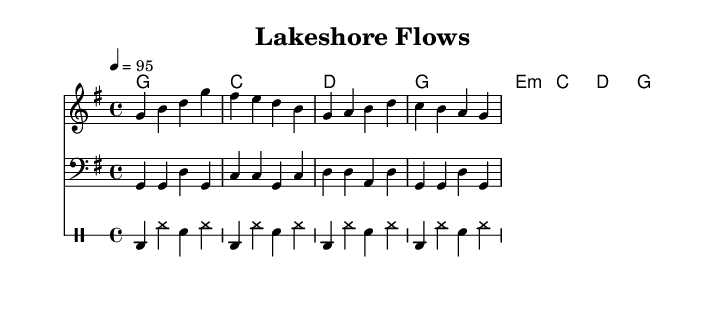What is the key signature of this music? The key signature indicated at the beginning of the score shows one sharp (F#), which corresponds to G major.
Answer: G major What is the time signature of the music? The time signature is located at the beginning of the score and shows a 4 over 4 arrangement, which indicates four beats per measure.
Answer: 4/4 What is the tempo marking for this piece? The tempo marking is given as 4 equals 95, meaning that there are 95 beats per minute in a quarter note.
Answer: 95 How many measures are in the melody section? By counting the groups separated by vertical lines (bar lines) in the melody staff, there are eight measures in total.
Answer: 8 What is the first lyric line in the verse? The first text line beneath the melody staff is "Cast a line, feel the breeze." This is what is sung in the first measure.
Answer: Cast a line, feel the breeze What rhythmic pattern is used in the drum section? The drum section comprises a bass drum played on the beat followed by hi-hats and snare on subdivided beats, maintaining a regular pattern throughout the section.
Answer: Regular pattern What type of chord progression is primarily used in the piece? The chord progression follows a common pattern of G, C, D, with variations that fit well within a hip-hop context, creating a cyclical feel.
Answer: G, C, D 